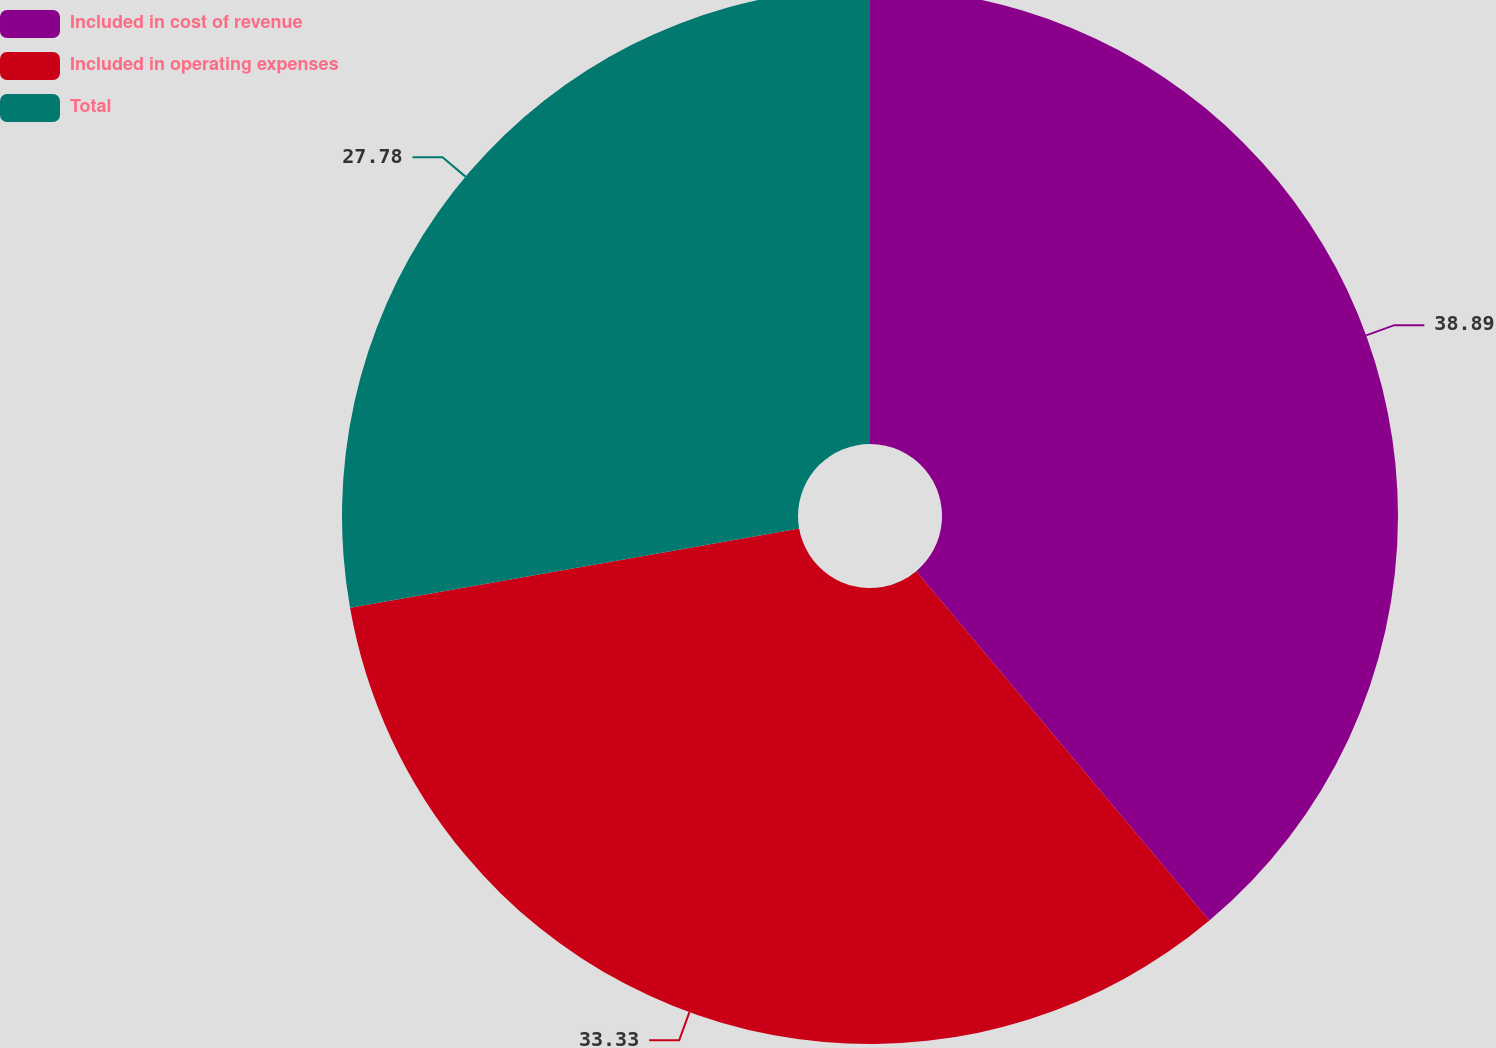Convert chart. <chart><loc_0><loc_0><loc_500><loc_500><pie_chart><fcel>Included in cost of revenue<fcel>Included in operating expenses<fcel>Total<nl><fcel>38.89%<fcel>33.33%<fcel>27.78%<nl></chart> 